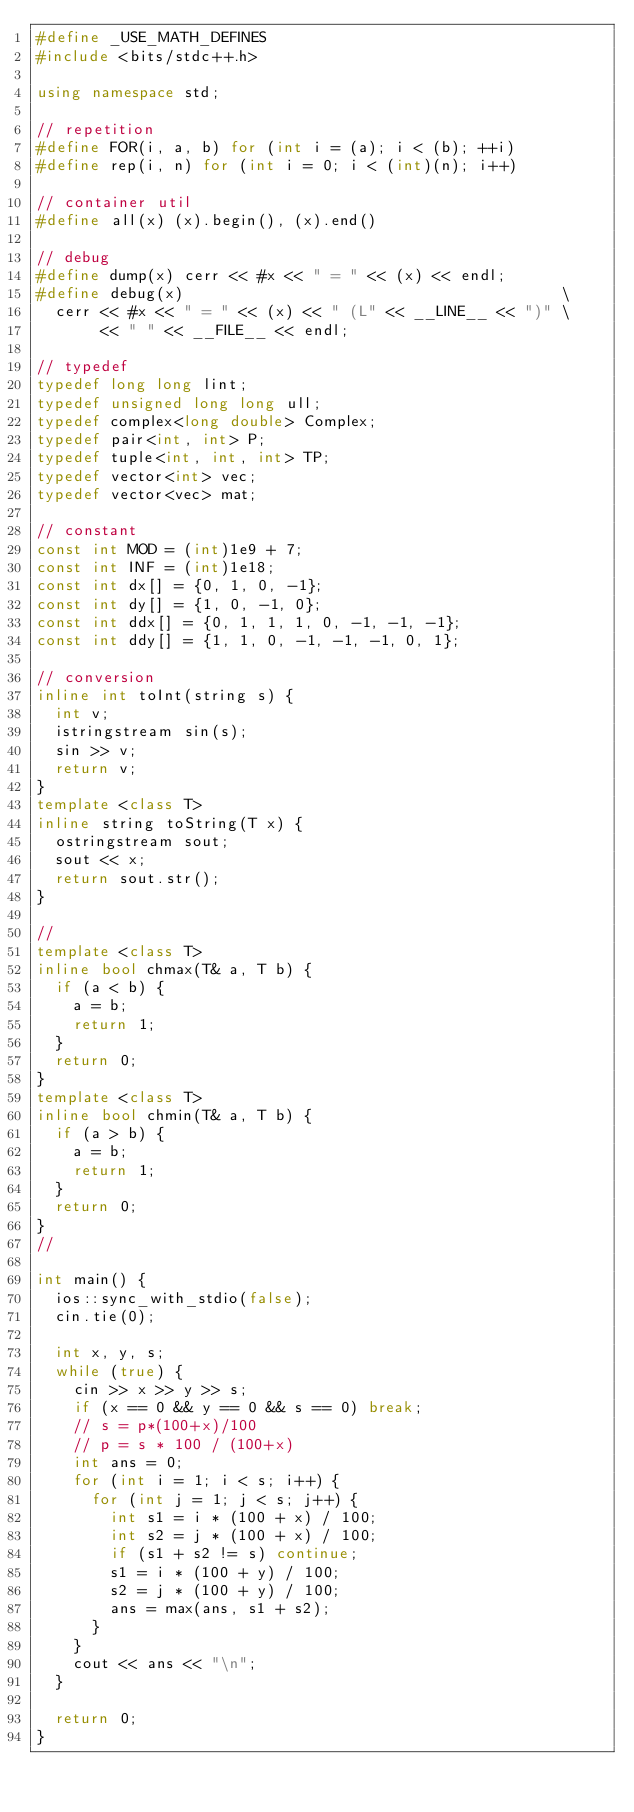<code> <loc_0><loc_0><loc_500><loc_500><_C++_>#define _USE_MATH_DEFINES
#include <bits/stdc++.h>

using namespace std;

// repetition
#define FOR(i, a, b) for (int i = (a); i < (b); ++i)
#define rep(i, n) for (int i = 0; i < (int)(n); i++)

// container util
#define all(x) (x).begin(), (x).end()

// debug
#define dump(x) cerr << #x << " = " << (x) << endl;
#define debug(x)                                         \
  cerr << #x << " = " << (x) << " (L" << __LINE__ << ")" \
       << " " << __FILE__ << endl;

// typedef
typedef long long lint;
typedef unsigned long long ull;
typedef complex<long double> Complex;
typedef pair<int, int> P;
typedef tuple<int, int, int> TP;
typedef vector<int> vec;
typedef vector<vec> mat;

// constant
const int MOD = (int)1e9 + 7;
const int INF = (int)1e18;
const int dx[] = {0, 1, 0, -1};
const int dy[] = {1, 0, -1, 0};
const int ddx[] = {0, 1, 1, 1, 0, -1, -1, -1};
const int ddy[] = {1, 1, 0, -1, -1, -1, 0, 1};

// conversion
inline int toInt(string s) {
  int v;
  istringstream sin(s);
  sin >> v;
  return v;
}
template <class T>
inline string toString(T x) {
  ostringstream sout;
  sout << x;
  return sout.str();
}

//
template <class T>
inline bool chmax(T& a, T b) {
  if (a < b) {
    a = b;
    return 1;
  }
  return 0;
}
template <class T>
inline bool chmin(T& a, T b) {
  if (a > b) {
    a = b;
    return 1;
  }
  return 0;
}
//

int main() {
  ios::sync_with_stdio(false);
  cin.tie(0);

  int x, y, s;
  while (true) {
    cin >> x >> y >> s;
    if (x == 0 && y == 0 && s == 0) break;
    // s = p*(100+x)/100
    // p = s * 100 / (100+x)
    int ans = 0;
    for (int i = 1; i < s; i++) {
      for (int j = 1; j < s; j++) {
        int s1 = i * (100 + x) / 100;
        int s2 = j * (100 + x) / 100;
        if (s1 + s2 != s) continue;
        s1 = i * (100 + y) / 100;
        s2 = j * (100 + y) / 100;
        ans = max(ans, s1 + s2);
      }
    }
    cout << ans << "\n";
  }

  return 0;
}
</code> 